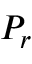Convert formula to latex. <formula><loc_0><loc_0><loc_500><loc_500>P _ { r }</formula> 